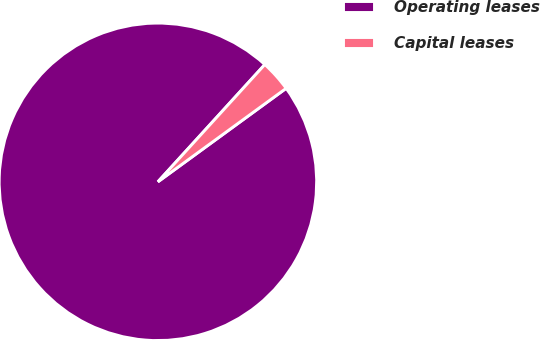Convert chart. <chart><loc_0><loc_0><loc_500><loc_500><pie_chart><fcel>Operating leases<fcel>Capital leases<nl><fcel>96.79%<fcel>3.21%<nl></chart> 